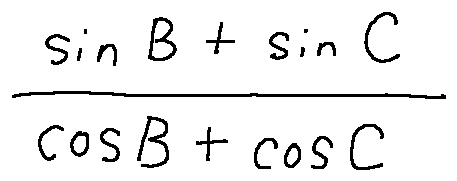<formula> <loc_0><loc_0><loc_500><loc_500>\frac { \sin B + \sin C } { \cos B + \cos C }</formula> 